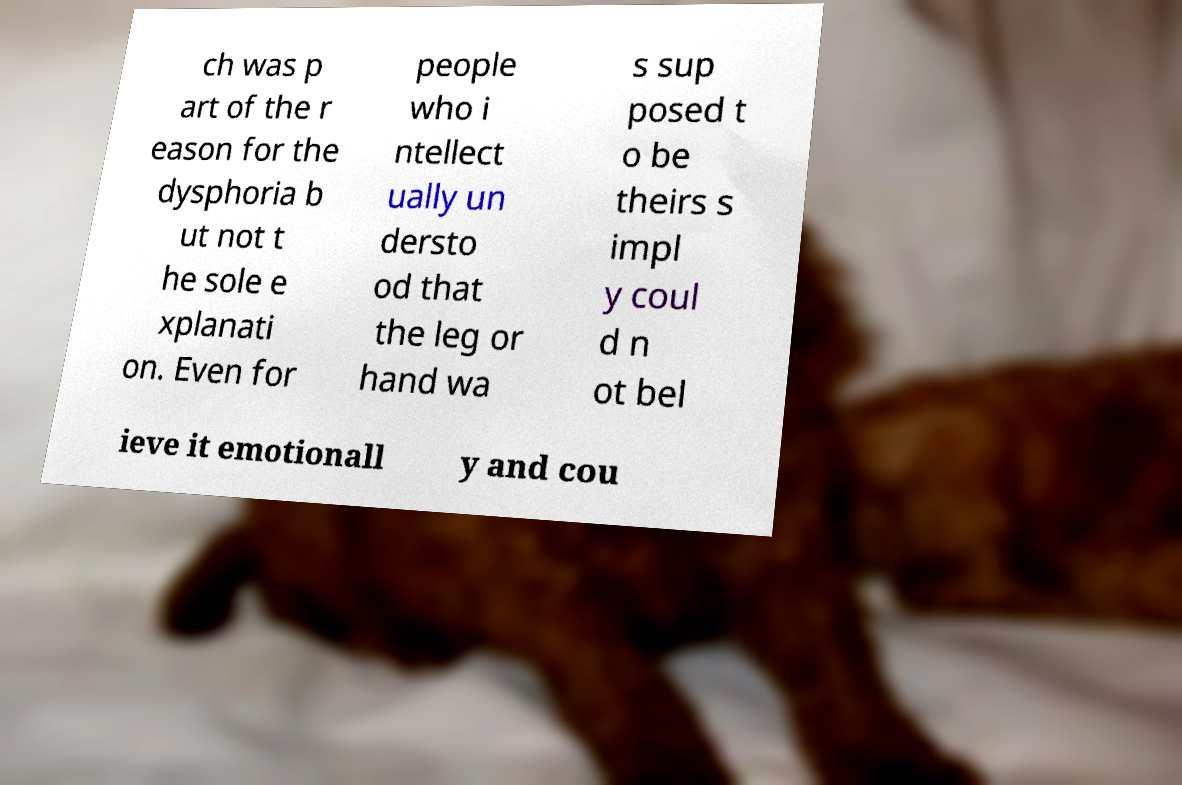Please identify and transcribe the text found in this image. ch was p art of the r eason for the dysphoria b ut not t he sole e xplanati on. Even for people who i ntellect ually un dersto od that the leg or hand wa s sup posed t o be theirs s impl y coul d n ot bel ieve it emotionall y and cou 